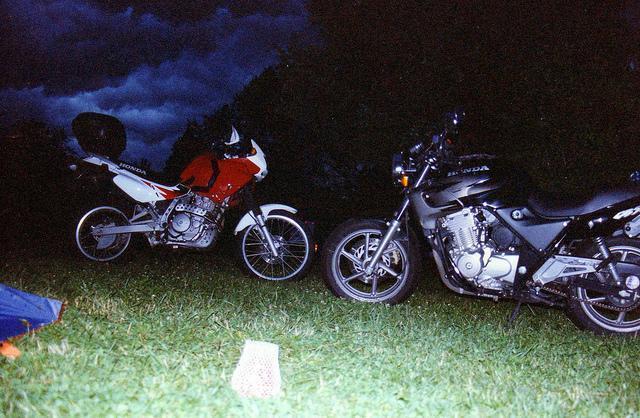How many motorcycles are in the picture?
Give a very brief answer. 2. 